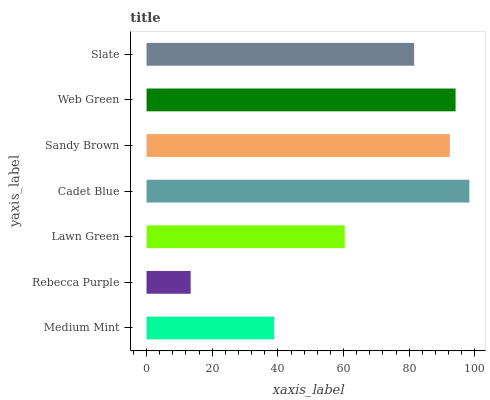Is Rebecca Purple the minimum?
Answer yes or no. Yes. Is Cadet Blue the maximum?
Answer yes or no. Yes. Is Lawn Green the minimum?
Answer yes or no. No. Is Lawn Green the maximum?
Answer yes or no. No. Is Lawn Green greater than Rebecca Purple?
Answer yes or no. Yes. Is Rebecca Purple less than Lawn Green?
Answer yes or no. Yes. Is Rebecca Purple greater than Lawn Green?
Answer yes or no. No. Is Lawn Green less than Rebecca Purple?
Answer yes or no. No. Is Slate the high median?
Answer yes or no. Yes. Is Slate the low median?
Answer yes or no. Yes. Is Medium Mint the high median?
Answer yes or no. No. Is Sandy Brown the low median?
Answer yes or no. No. 